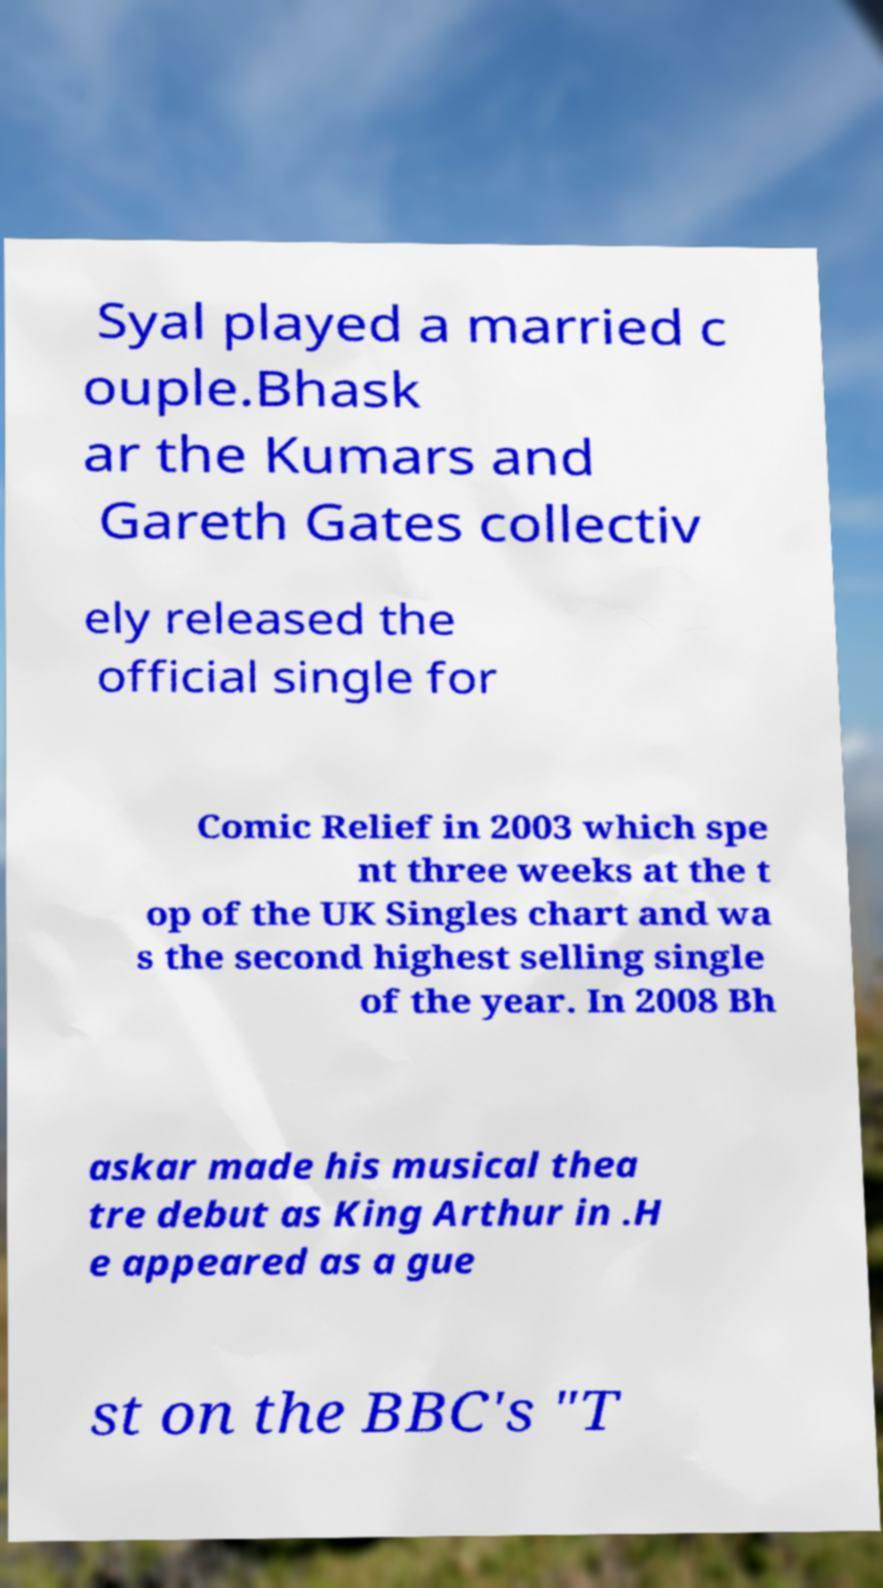There's text embedded in this image that I need extracted. Can you transcribe it verbatim? Syal played a married c ouple.Bhask ar the Kumars and Gareth Gates collectiv ely released the official single for Comic Relief in 2003 which spe nt three weeks at the t op of the UK Singles chart and wa s the second highest selling single of the year. In 2008 Bh askar made his musical thea tre debut as King Arthur in .H e appeared as a gue st on the BBC's "T 